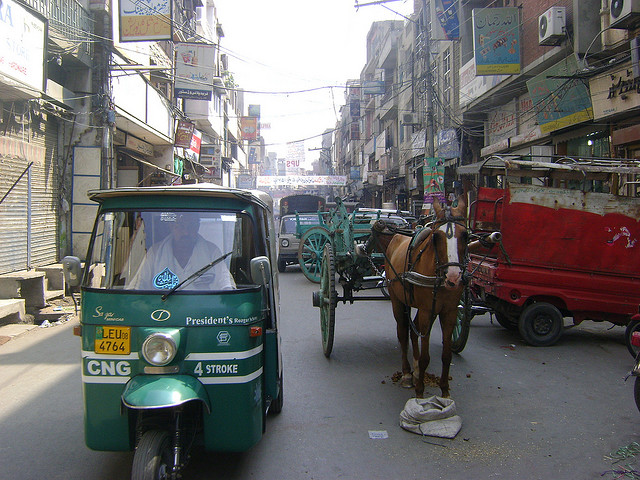Read and extract the text from this image. CNG Presidents's STROKE 4 LEU A 4764 